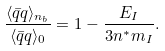Convert formula to latex. <formula><loc_0><loc_0><loc_500><loc_500>\frac { \langle \bar { q } q \rangle _ { n _ { b } } } { \langle \bar { q } q \rangle _ { 0 } } = 1 - \frac { E _ { I } } { 3 n ^ { * } m _ { I } } .</formula> 